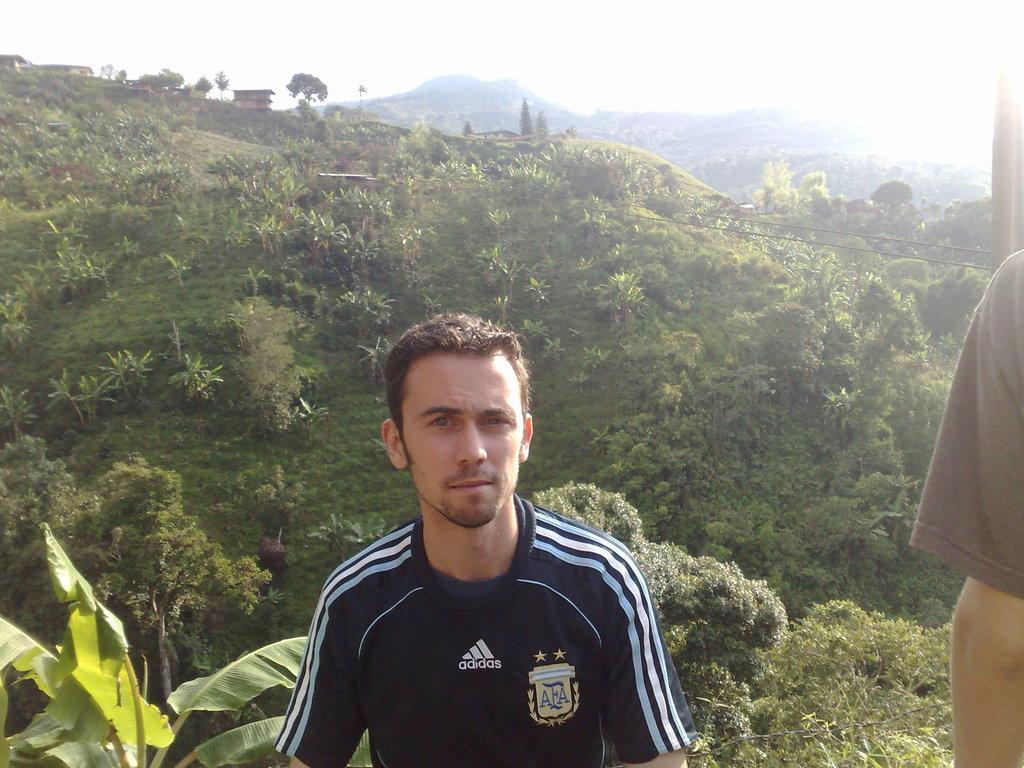Describe this image in one or two sentences. In this picture, there is a man at the bottom. He is wearing a blue t shirt. Towards the right, there is another person. In the background there are hills with grass and plants. On the top, there is a sky. 